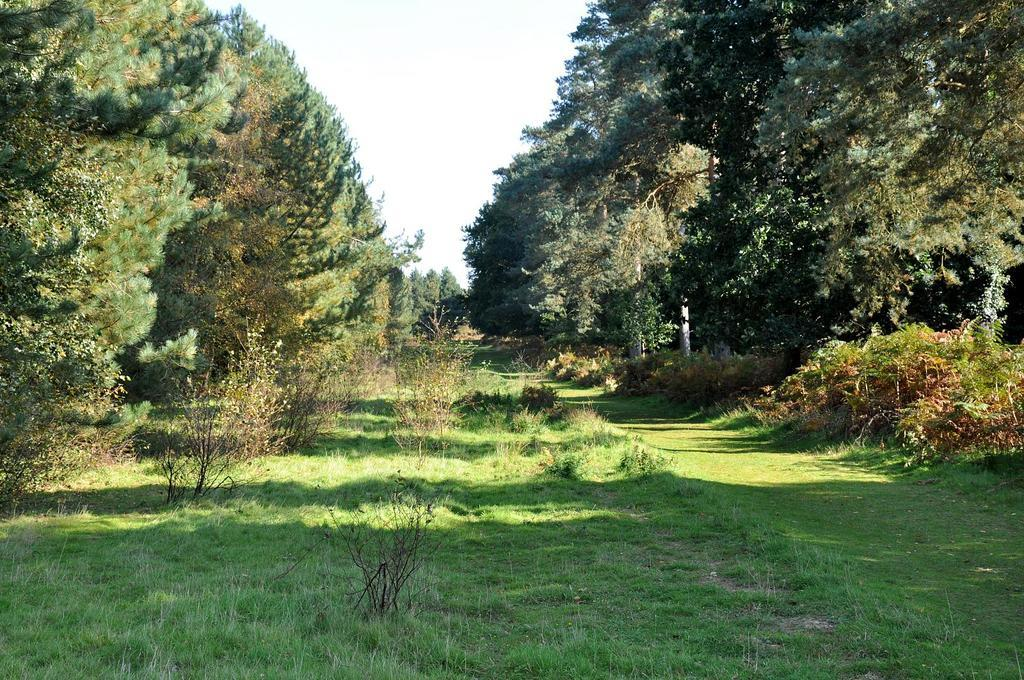What type of vegetation is present in the image? There are many trees in the image. What is the color of the grass on the ground in the image? The grass on the ground in the image is green. What part of the natural environment is visible in the image? The sky is visible at the top of the image. How many baskets can be seen hanging from the trees in the image? There are no baskets present in the image; it features trees and green grass. Who is the representative of the trees in the image? There is no representative for the trees in the image, as they are not sentient beings. 